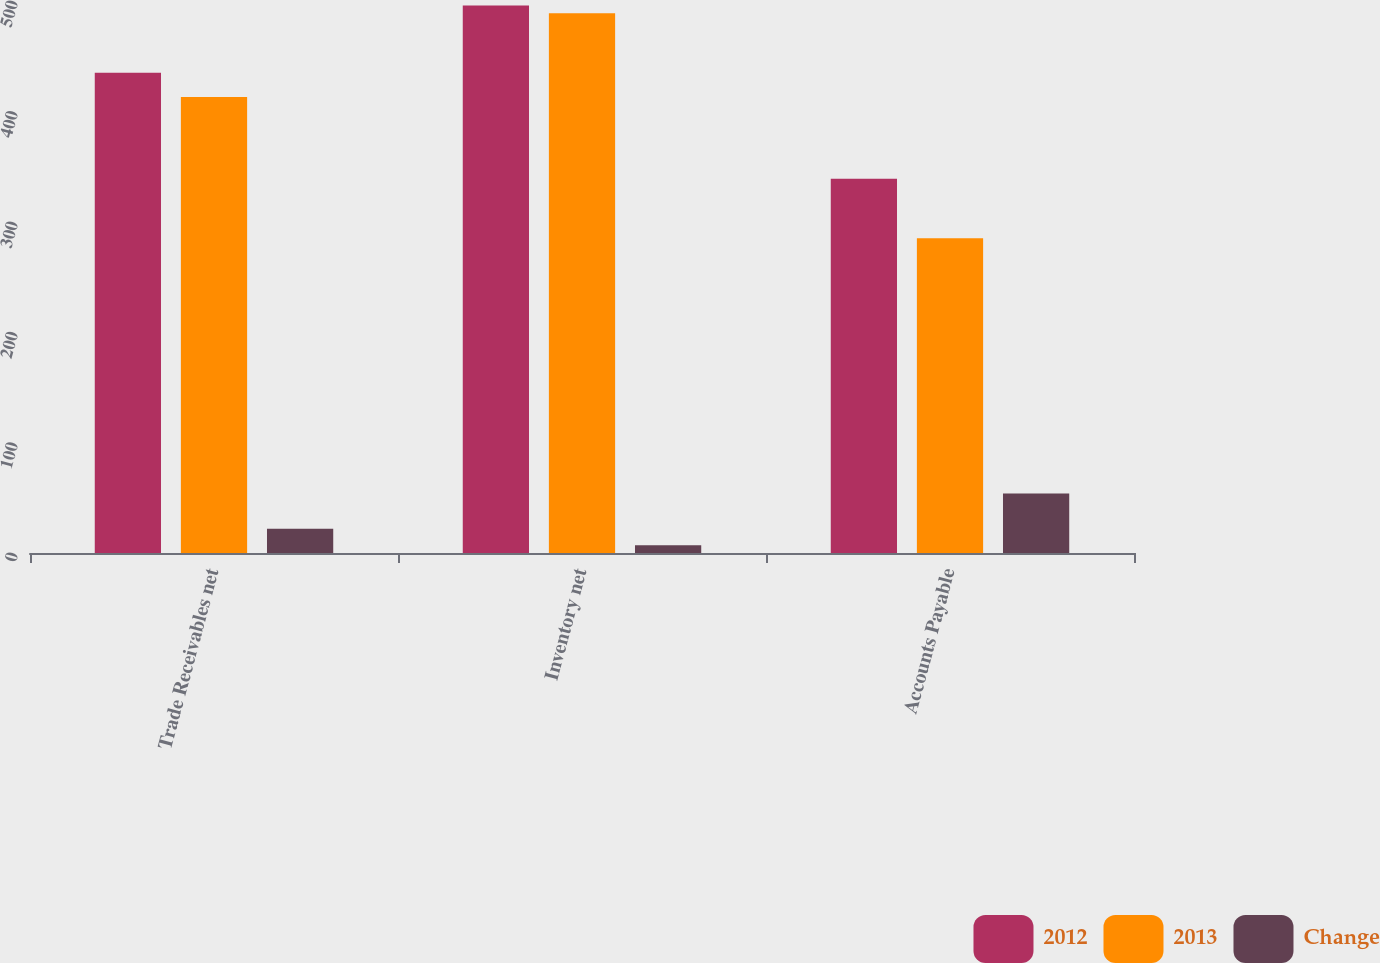<chart> <loc_0><loc_0><loc_500><loc_500><stacked_bar_chart><ecel><fcel>Trade Receivables net<fcel>Inventory net<fcel>Accounts Payable<nl><fcel>2012<fcel>435<fcel>496<fcel>339<nl><fcel>2013<fcel>413<fcel>489<fcel>285<nl><fcel>Change<fcel>22<fcel>7<fcel>54<nl></chart> 